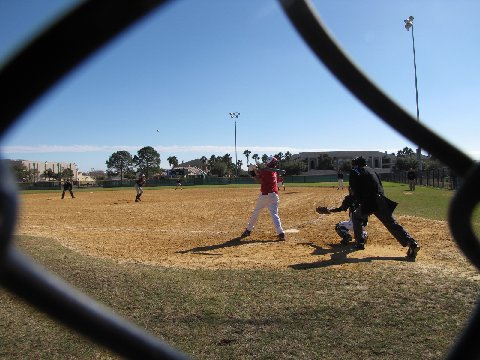Can you describe the team uniforms and any distinguishing features the players may have? Observing the team attire, the young athletes are decked out in vibrant uniform colors, each with distinctive numbers and perhaps a team logo emblazoned on their jerseys, giving us a splash of their team identity. Helmets and gloves also adorn the players, ensuring safety as well as uniformity on the field. 